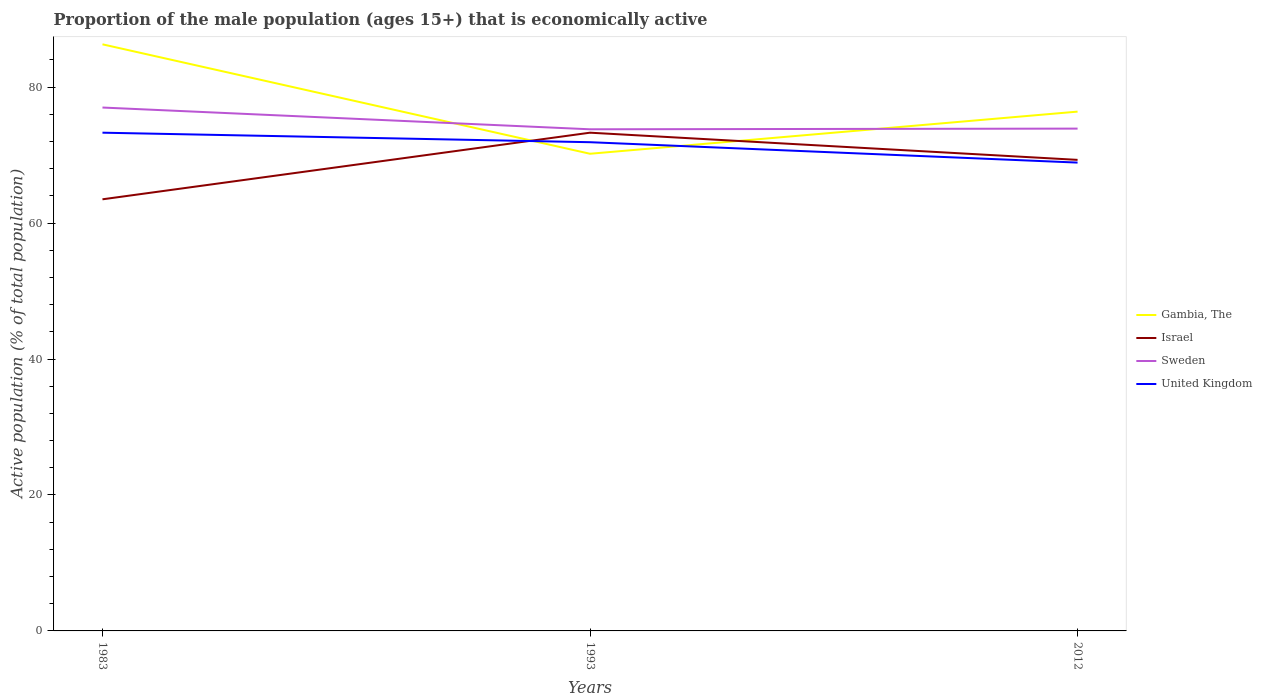How many different coloured lines are there?
Ensure brevity in your answer.  4. Is the number of lines equal to the number of legend labels?
Keep it short and to the point. Yes. Across all years, what is the maximum proportion of the male population that is economically active in United Kingdom?
Keep it short and to the point. 68.9. What is the total proportion of the male population that is economically active in United Kingdom in the graph?
Keep it short and to the point. 1.4. What is the difference between the highest and the second highest proportion of the male population that is economically active in Gambia, The?
Your response must be concise. 16.1. Is the proportion of the male population that is economically active in United Kingdom strictly greater than the proportion of the male population that is economically active in Israel over the years?
Provide a succinct answer. No. How many lines are there?
Provide a succinct answer. 4. How many years are there in the graph?
Your response must be concise. 3. What is the difference between two consecutive major ticks on the Y-axis?
Your answer should be compact. 20. What is the title of the graph?
Keep it short and to the point. Proportion of the male population (ages 15+) that is economically active. Does "Uzbekistan" appear as one of the legend labels in the graph?
Offer a terse response. No. What is the label or title of the Y-axis?
Your answer should be compact. Active population (% of total population). What is the Active population (% of total population) in Gambia, The in 1983?
Keep it short and to the point. 86.3. What is the Active population (% of total population) in Israel in 1983?
Give a very brief answer. 63.5. What is the Active population (% of total population) of Sweden in 1983?
Ensure brevity in your answer.  77. What is the Active population (% of total population) in United Kingdom in 1983?
Offer a very short reply. 73.3. What is the Active population (% of total population) of Gambia, The in 1993?
Provide a short and direct response. 70.2. What is the Active population (% of total population) in Israel in 1993?
Your answer should be compact. 73.3. What is the Active population (% of total population) of Sweden in 1993?
Keep it short and to the point. 73.8. What is the Active population (% of total population) in United Kingdom in 1993?
Your answer should be very brief. 71.9. What is the Active population (% of total population) of Gambia, The in 2012?
Ensure brevity in your answer.  76.4. What is the Active population (% of total population) of Israel in 2012?
Keep it short and to the point. 69.3. What is the Active population (% of total population) in Sweden in 2012?
Your answer should be compact. 73.9. What is the Active population (% of total population) in United Kingdom in 2012?
Provide a short and direct response. 68.9. Across all years, what is the maximum Active population (% of total population) in Gambia, The?
Your answer should be very brief. 86.3. Across all years, what is the maximum Active population (% of total population) in Israel?
Provide a short and direct response. 73.3. Across all years, what is the maximum Active population (% of total population) of United Kingdom?
Make the answer very short. 73.3. Across all years, what is the minimum Active population (% of total population) of Gambia, The?
Your answer should be compact. 70.2. Across all years, what is the minimum Active population (% of total population) in Israel?
Your response must be concise. 63.5. Across all years, what is the minimum Active population (% of total population) in Sweden?
Provide a short and direct response. 73.8. Across all years, what is the minimum Active population (% of total population) of United Kingdom?
Provide a short and direct response. 68.9. What is the total Active population (% of total population) of Gambia, The in the graph?
Provide a short and direct response. 232.9. What is the total Active population (% of total population) of Israel in the graph?
Give a very brief answer. 206.1. What is the total Active population (% of total population) in Sweden in the graph?
Offer a terse response. 224.7. What is the total Active population (% of total population) in United Kingdom in the graph?
Your answer should be very brief. 214.1. What is the difference between the Active population (% of total population) of Gambia, The in 1983 and that in 1993?
Provide a short and direct response. 16.1. What is the difference between the Active population (% of total population) of Israel in 1983 and that in 1993?
Make the answer very short. -9.8. What is the difference between the Active population (% of total population) of Sweden in 1983 and that in 2012?
Offer a very short reply. 3.1. What is the difference between the Active population (% of total population) of Gambia, The in 1993 and that in 2012?
Your answer should be compact. -6.2. What is the difference between the Active population (% of total population) of Sweden in 1993 and that in 2012?
Make the answer very short. -0.1. What is the difference between the Active population (% of total population) in United Kingdom in 1993 and that in 2012?
Your answer should be compact. 3. What is the difference between the Active population (% of total population) of Gambia, The in 1983 and the Active population (% of total population) of Israel in 1993?
Provide a succinct answer. 13. What is the difference between the Active population (% of total population) of Gambia, The in 1983 and the Active population (% of total population) of Sweden in 1993?
Provide a succinct answer. 12.5. What is the difference between the Active population (% of total population) in Israel in 1983 and the Active population (% of total population) in Sweden in 1993?
Your response must be concise. -10.3. What is the difference between the Active population (% of total population) in Israel in 1983 and the Active population (% of total population) in United Kingdom in 1993?
Your answer should be compact. -8.4. What is the difference between the Active population (% of total population) in Sweden in 1983 and the Active population (% of total population) in United Kingdom in 1993?
Offer a very short reply. 5.1. What is the difference between the Active population (% of total population) in Gambia, The in 1983 and the Active population (% of total population) in United Kingdom in 2012?
Your answer should be compact. 17.4. What is the difference between the Active population (% of total population) of Gambia, The in 1993 and the Active population (% of total population) of Israel in 2012?
Keep it short and to the point. 0.9. What is the difference between the Active population (% of total population) in Gambia, The in 1993 and the Active population (% of total population) in United Kingdom in 2012?
Keep it short and to the point. 1.3. What is the difference between the Active population (% of total population) in Israel in 1993 and the Active population (% of total population) in Sweden in 2012?
Provide a short and direct response. -0.6. What is the difference between the Active population (% of total population) in Sweden in 1993 and the Active population (% of total population) in United Kingdom in 2012?
Your answer should be very brief. 4.9. What is the average Active population (% of total population) in Gambia, The per year?
Offer a terse response. 77.63. What is the average Active population (% of total population) in Israel per year?
Offer a terse response. 68.7. What is the average Active population (% of total population) of Sweden per year?
Give a very brief answer. 74.9. What is the average Active population (% of total population) in United Kingdom per year?
Your answer should be very brief. 71.37. In the year 1983, what is the difference between the Active population (% of total population) of Gambia, The and Active population (% of total population) of Israel?
Ensure brevity in your answer.  22.8. In the year 1983, what is the difference between the Active population (% of total population) in Gambia, The and Active population (% of total population) in United Kingdom?
Give a very brief answer. 13. In the year 1983, what is the difference between the Active population (% of total population) of Israel and Active population (% of total population) of Sweden?
Give a very brief answer. -13.5. In the year 1983, what is the difference between the Active population (% of total population) in Sweden and Active population (% of total population) in United Kingdom?
Offer a very short reply. 3.7. In the year 1993, what is the difference between the Active population (% of total population) of Gambia, The and Active population (% of total population) of Israel?
Your answer should be compact. -3.1. In the year 1993, what is the difference between the Active population (% of total population) of Israel and Active population (% of total population) of Sweden?
Keep it short and to the point. -0.5. In the year 1993, what is the difference between the Active population (% of total population) in Israel and Active population (% of total population) in United Kingdom?
Offer a very short reply. 1.4. In the year 1993, what is the difference between the Active population (% of total population) of Sweden and Active population (% of total population) of United Kingdom?
Provide a succinct answer. 1.9. In the year 2012, what is the difference between the Active population (% of total population) in Gambia, The and Active population (% of total population) in Israel?
Provide a succinct answer. 7.1. In the year 2012, what is the difference between the Active population (% of total population) of Israel and Active population (% of total population) of Sweden?
Make the answer very short. -4.6. In the year 2012, what is the difference between the Active population (% of total population) in Sweden and Active population (% of total population) in United Kingdom?
Your response must be concise. 5. What is the ratio of the Active population (% of total population) in Gambia, The in 1983 to that in 1993?
Give a very brief answer. 1.23. What is the ratio of the Active population (% of total population) of Israel in 1983 to that in 1993?
Provide a short and direct response. 0.87. What is the ratio of the Active population (% of total population) in Sweden in 1983 to that in 1993?
Your response must be concise. 1.04. What is the ratio of the Active population (% of total population) in United Kingdom in 1983 to that in 1993?
Offer a very short reply. 1.02. What is the ratio of the Active population (% of total population) of Gambia, The in 1983 to that in 2012?
Give a very brief answer. 1.13. What is the ratio of the Active population (% of total population) of Israel in 1983 to that in 2012?
Provide a succinct answer. 0.92. What is the ratio of the Active population (% of total population) of Sweden in 1983 to that in 2012?
Your answer should be compact. 1.04. What is the ratio of the Active population (% of total population) in United Kingdom in 1983 to that in 2012?
Offer a terse response. 1.06. What is the ratio of the Active population (% of total population) of Gambia, The in 1993 to that in 2012?
Offer a terse response. 0.92. What is the ratio of the Active population (% of total population) in Israel in 1993 to that in 2012?
Ensure brevity in your answer.  1.06. What is the ratio of the Active population (% of total population) of Sweden in 1993 to that in 2012?
Offer a terse response. 1. What is the ratio of the Active population (% of total population) in United Kingdom in 1993 to that in 2012?
Make the answer very short. 1.04. What is the difference between the highest and the second highest Active population (% of total population) in Israel?
Provide a short and direct response. 4. What is the difference between the highest and the lowest Active population (% of total population) of United Kingdom?
Keep it short and to the point. 4.4. 